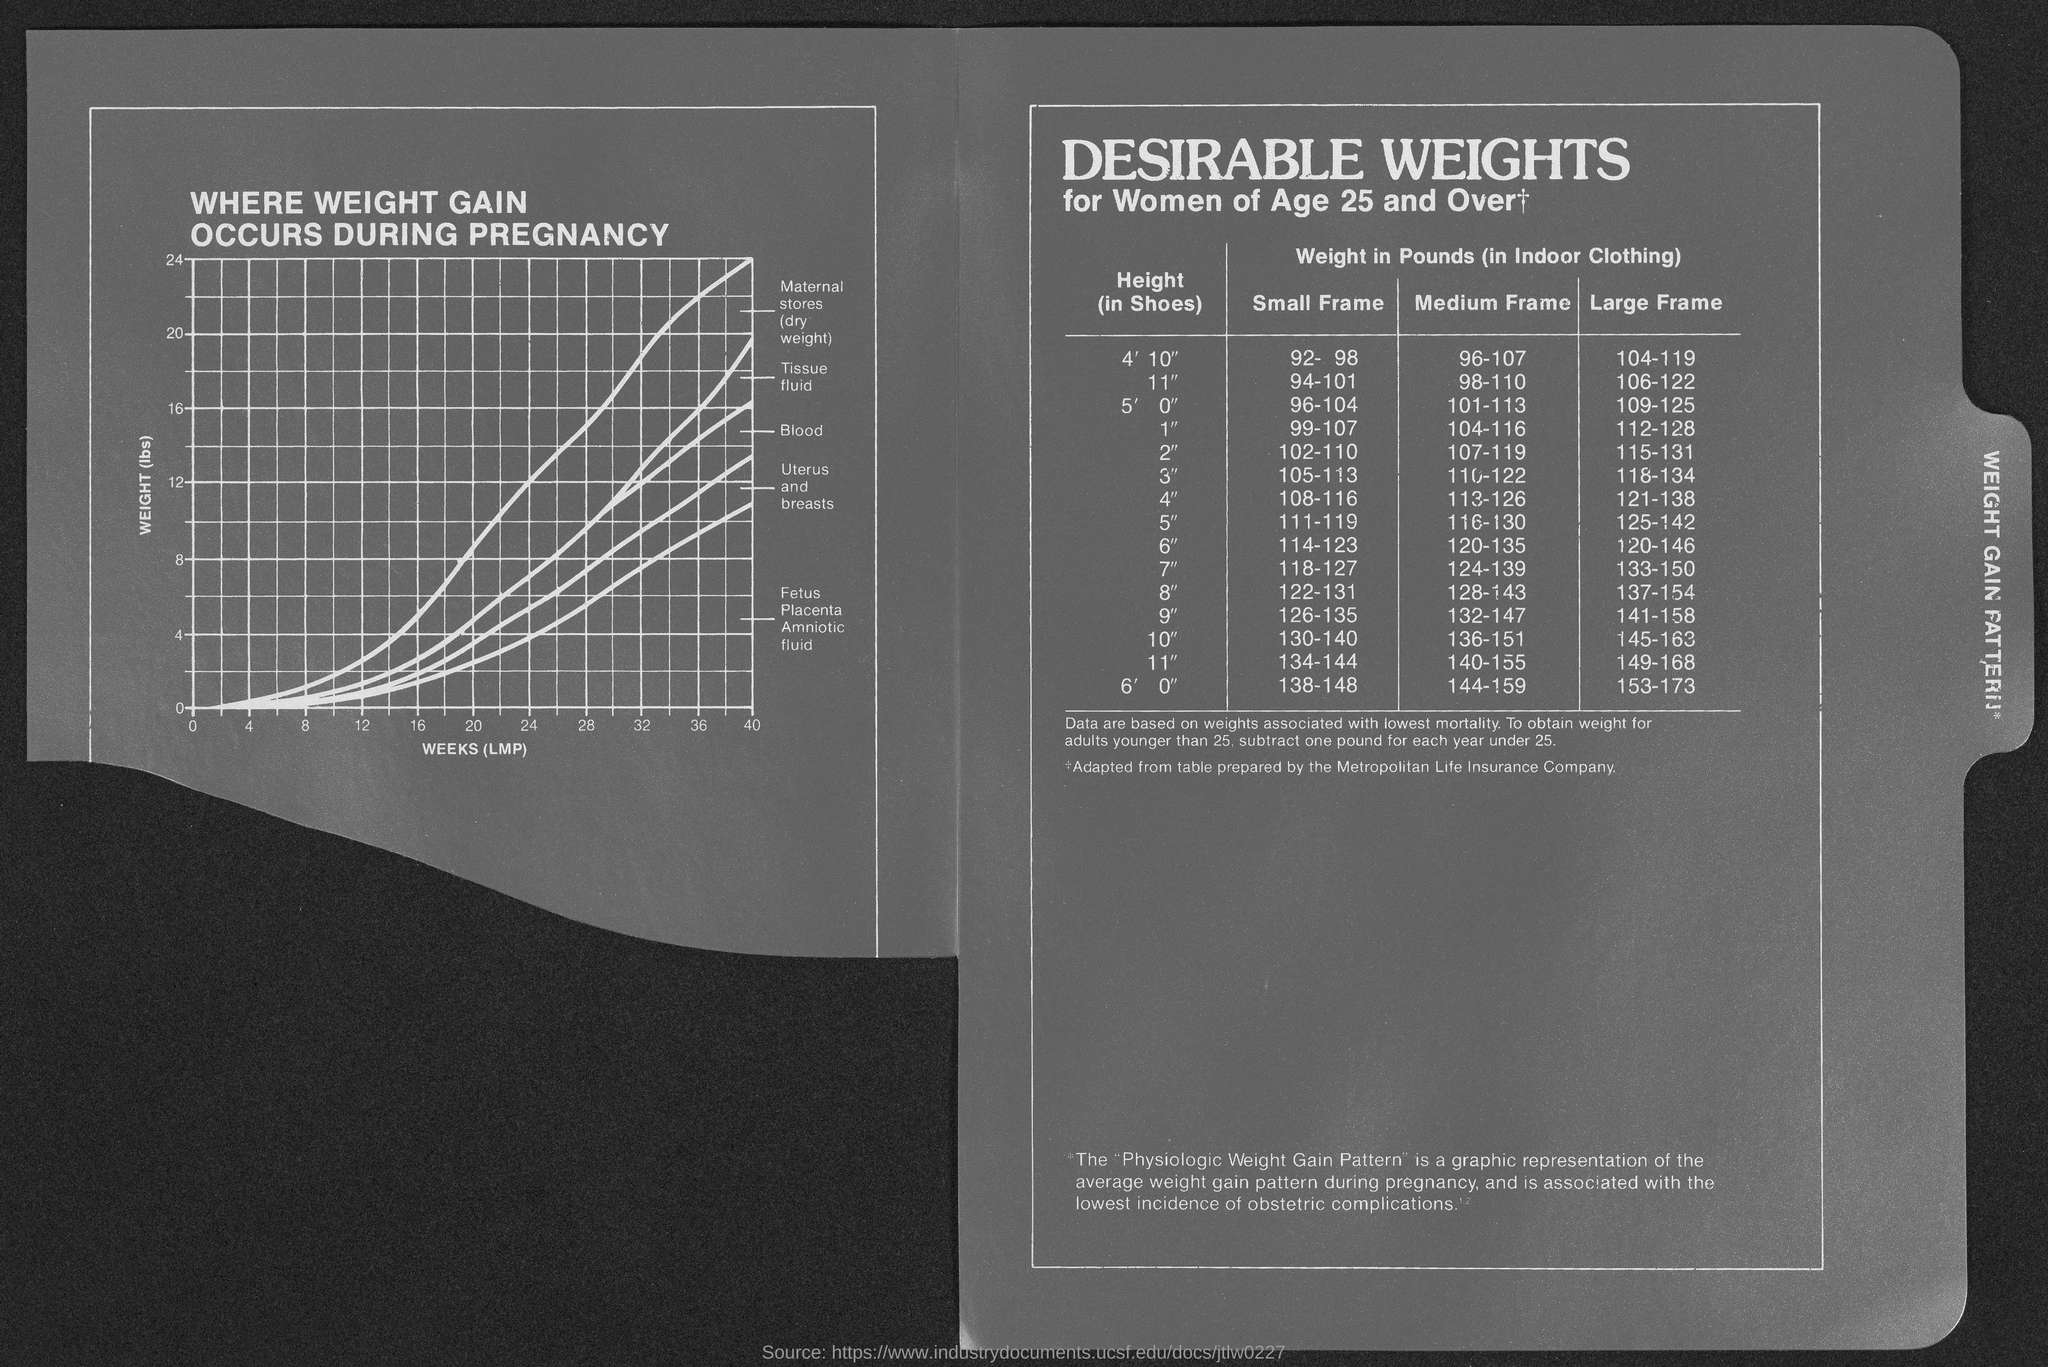Indicate a few pertinent items in this graphic. The weight (lbs) is on the y-axis of the graph. The title of the graph is 'Where Weight Gain Occurs During Pregnancy'. The x-axis of the graph represents the weeks of pregnancy, specifically, the last menstrual period (LMP). This table is titled 'Desirable Weights for Women Aged 25 and Over.' 